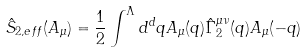<formula> <loc_0><loc_0><loc_500><loc_500>\hat { S } _ { 2 , e f f } ( A _ { \mu } ) = \frac { 1 } { 2 } \int ^ { \Lambda } d ^ { d } q A _ { \mu } ( q ) \hat { \Gamma } _ { 2 } ^ { \mu \nu } ( q ) A _ { \mu } ( - q )</formula> 